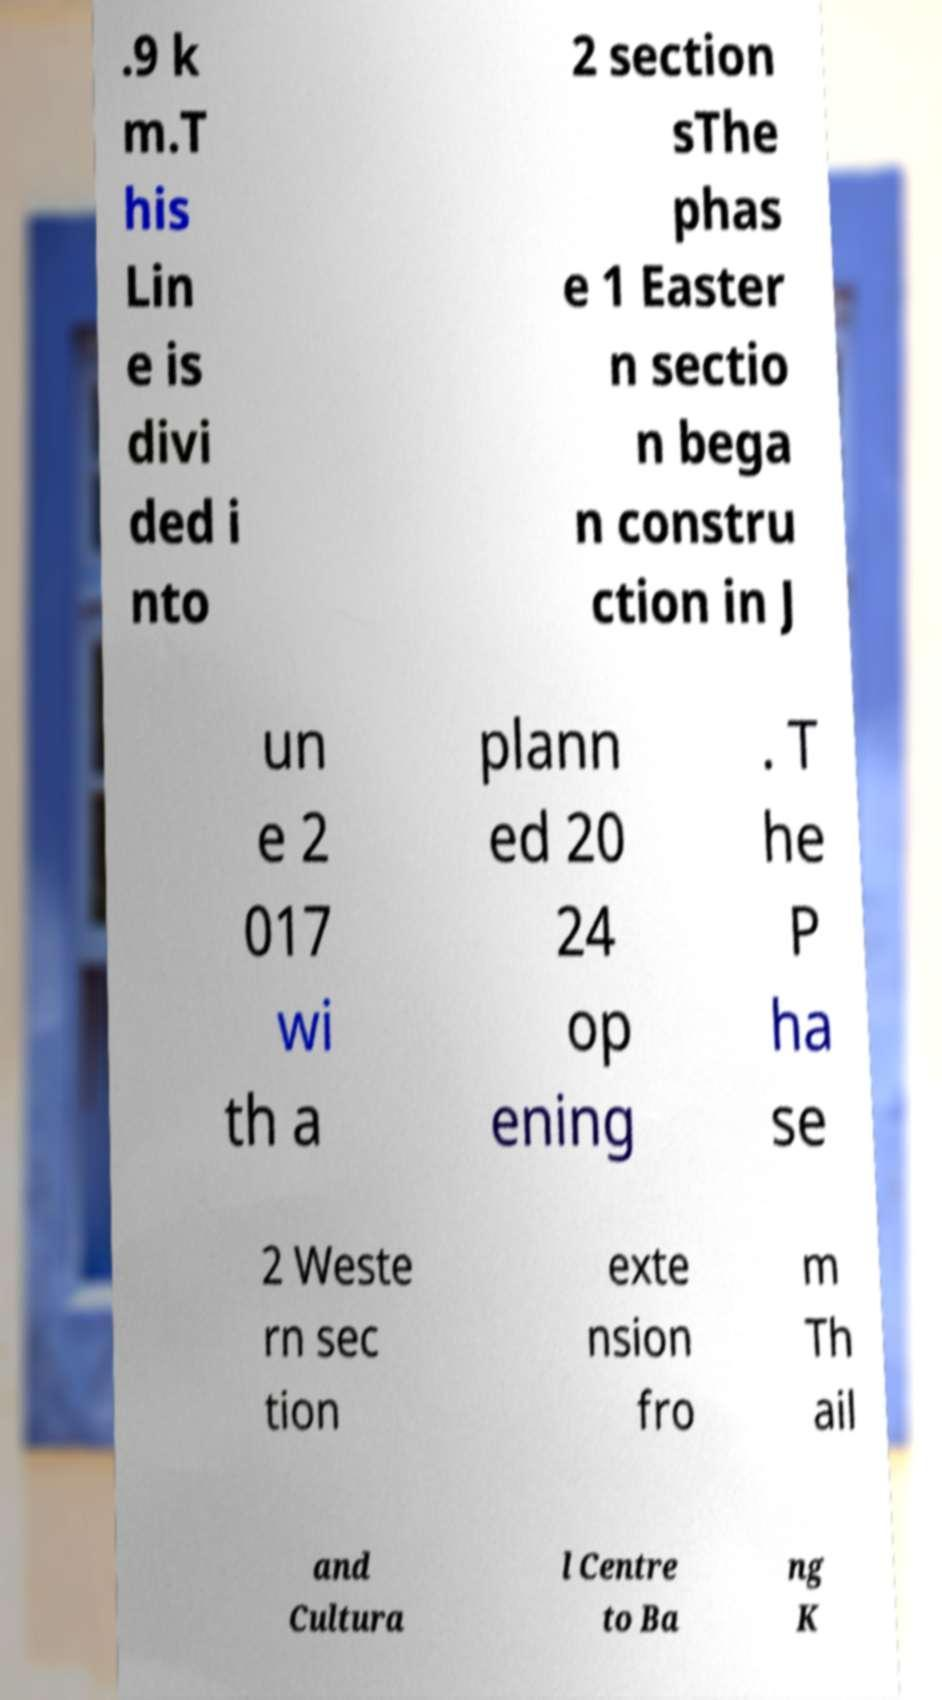There's text embedded in this image that I need extracted. Can you transcribe it verbatim? .9 k m.T his Lin e is divi ded i nto 2 section sThe phas e 1 Easter n sectio n bega n constru ction in J un e 2 017 wi th a plann ed 20 24 op ening . T he P ha se 2 Weste rn sec tion exte nsion fro m Th ail and Cultura l Centre to Ba ng K 